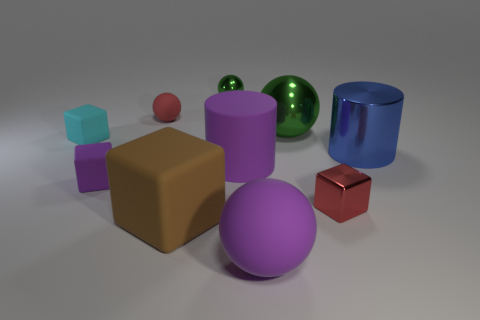Subtract all tiny red spheres. How many spheres are left? 3 Subtract 1 balls. How many balls are left? 3 Subtract all blue blocks. Subtract all yellow cylinders. How many blocks are left? 4 Subtract all cylinders. How many objects are left? 8 Subtract all big green spheres. Subtract all red cubes. How many objects are left? 8 Add 2 tiny red spheres. How many tiny red spheres are left? 3 Add 7 big blue shiny things. How many big blue shiny things exist? 8 Subtract 0 blue spheres. How many objects are left? 10 